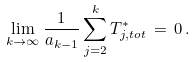Convert formula to latex. <formula><loc_0><loc_0><loc_500><loc_500>\lim _ { k \rightarrow \infty } \frac { 1 } { a _ { k - 1 } } \sum _ { j = 2 } ^ { k } T ^ { * } _ { j , t o t } \, = \, 0 \, .</formula> 